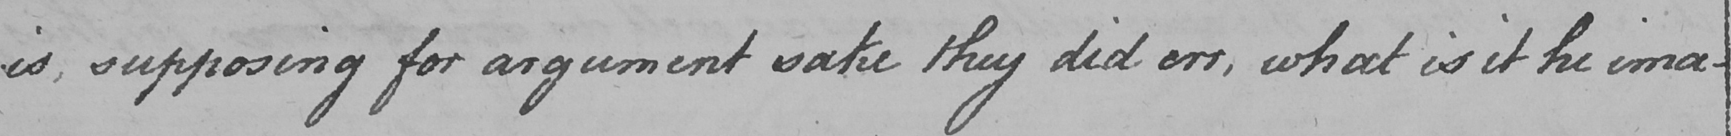Please provide the text content of this handwritten line. is , supposing for argument sake they did err , what is it he ima- 